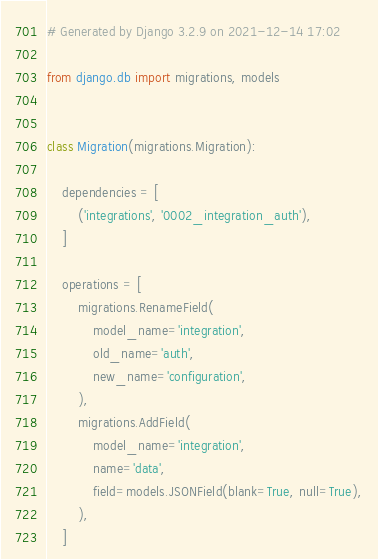Convert code to text. <code><loc_0><loc_0><loc_500><loc_500><_Python_># Generated by Django 3.2.9 on 2021-12-14 17:02

from django.db import migrations, models


class Migration(migrations.Migration):

    dependencies = [
        ('integrations', '0002_integration_auth'),
    ]

    operations = [
        migrations.RenameField(
            model_name='integration',
            old_name='auth',
            new_name='configuration',
        ),
        migrations.AddField(
            model_name='integration',
            name='data',
            field=models.JSONField(blank=True, null=True),
        ),
    ]
</code> 